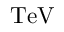<formula> <loc_0><loc_0><loc_500><loc_500>T e V</formula> 